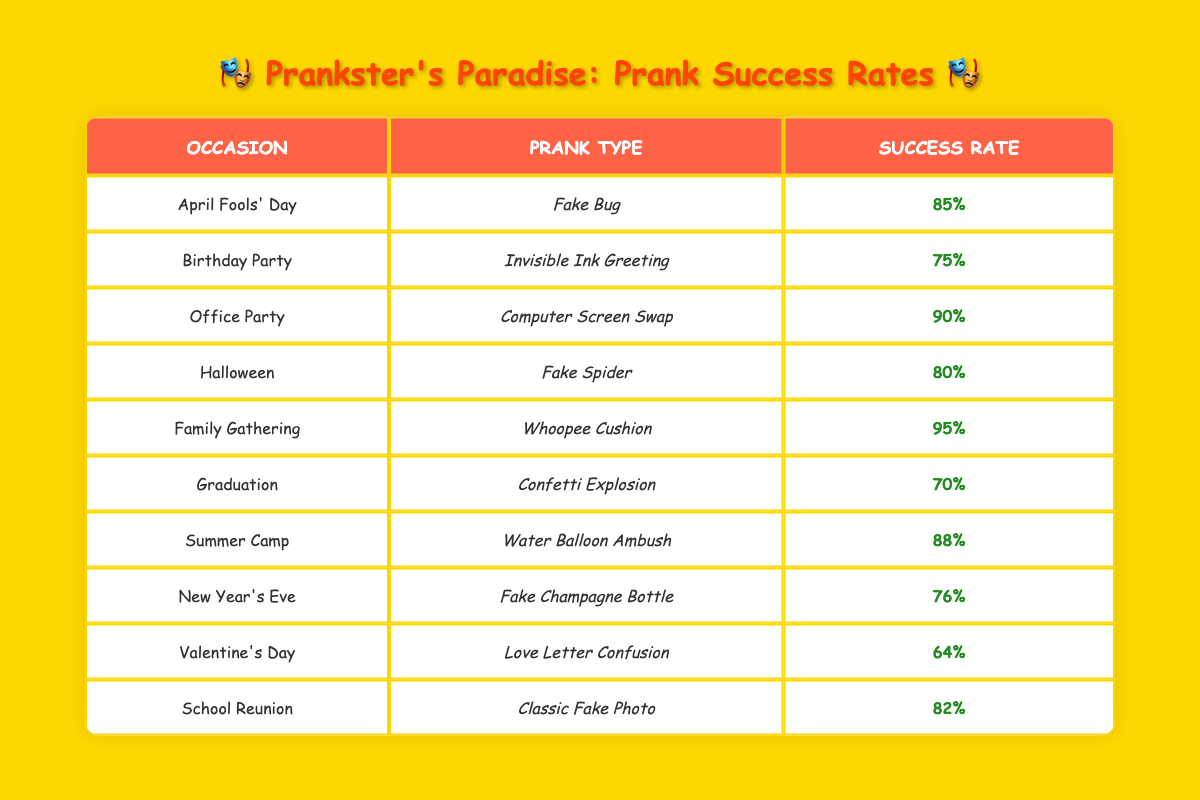What is the success rate of the Whoopee Cushion prank? The table shows that the success rate for the Whoopee Cushion prank, which is under the Family Gathering occasion, is 95%.
Answer: 95% Which occasion has the highest success rate? Looking through the success rates listed, the Family Gathering with the Whoopee Cushion prank holds the highest success rate at 95%.
Answer: Family Gathering Is the success rate of the Fake Bug prank above 80%? The table states that the Fake Bug prank has a success rate of 85%, which is indeed above 80%.
Answer: Yes What is the average success rate of pranks for Valentine’s Day, Graduation, and Birthday Party? The success rates for these pranks are 64% (Valentine's Day), 70% (Graduation), and 75% (Birthday Party). To find the average, add these (64 + 70 + 75 = 209) and divide by 3, resulting in an average of 69.67%.
Answer: 69.67% Which prank has a lower success rate, Invisible Ink Greeting or Love Letter Confusion? From the table, the Invisible Ink Greeting has a success rate of 75%, while the Love Letter Confusion has a success rate of 64%. Comparing these rates reveals that Love Letter Confusion has a lower success rate.
Answer: Love Letter Confusion What is the difference in success rates between the Office Party and Halloween pranks? The Office Party prank has a success rate of 90%, and the Halloween prank has a success rate of 80%. The difference can be calculated by subtracting 80 from 90, giving us a difference of 10%.
Answer: 10% Are the success rates of all pranks listed above 60%? Checking the table, the lowest rate is for Love Letter Confusion, which is at 64%, therefore all listed pranks have success rates above 60%.
Answer: Yes What two occasions have success rates above 80% and are related to gatherings or celebrations? We see that Family Gathering (95%) and Summer Camp (88%) are occasions related to gatherings or celebrations with success rates above 80%.
Answer: Family Gathering and Summer Camp 